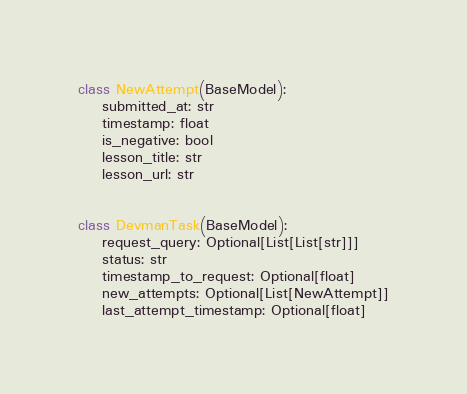<code> <loc_0><loc_0><loc_500><loc_500><_Python_>class NewAttempt(BaseModel):
    submitted_at: str
    timestamp: float
    is_negative: bool
    lesson_title: str
    lesson_url: str


class DevmanTask(BaseModel):
    request_query: Optional[List[List[str]]]
    status: str
    timestamp_to_request: Optional[float]
    new_attempts: Optional[List[NewAttempt]]
    last_attempt_timestamp: Optional[float]
</code> 